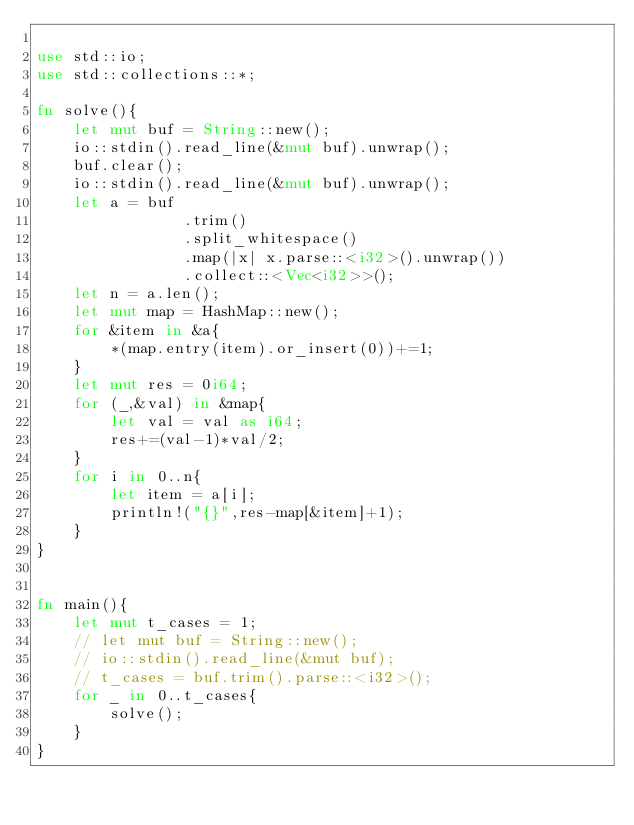Convert code to text. <code><loc_0><loc_0><loc_500><loc_500><_Rust_>
use std::io;
use std::collections::*;

fn solve(){
    let mut buf = String::new();
    io::stdin().read_line(&mut buf).unwrap();
    buf.clear();
    io::stdin().read_line(&mut buf).unwrap();
    let a = buf
                .trim()
                .split_whitespace()
                .map(|x| x.parse::<i32>().unwrap())
                .collect::<Vec<i32>>();
    let n = a.len();
    let mut map = HashMap::new();
    for &item in &a{
        *(map.entry(item).or_insert(0))+=1;
    }
    let mut res = 0i64;
    for (_,&val) in &map{
        let val = val as i64;
        res+=(val-1)*val/2;
    }
    for i in 0..n{
        let item = a[i];
        println!("{}",res-map[&item]+1);
    }
}


fn main(){
    let mut t_cases = 1;
    // let mut buf = String::new();
    // io::stdin().read_line(&mut buf);
    // t_cases = buf.trim().parse::<i32>();
    for _ in 0..t_cases{
        solve();
    }
}</code> 